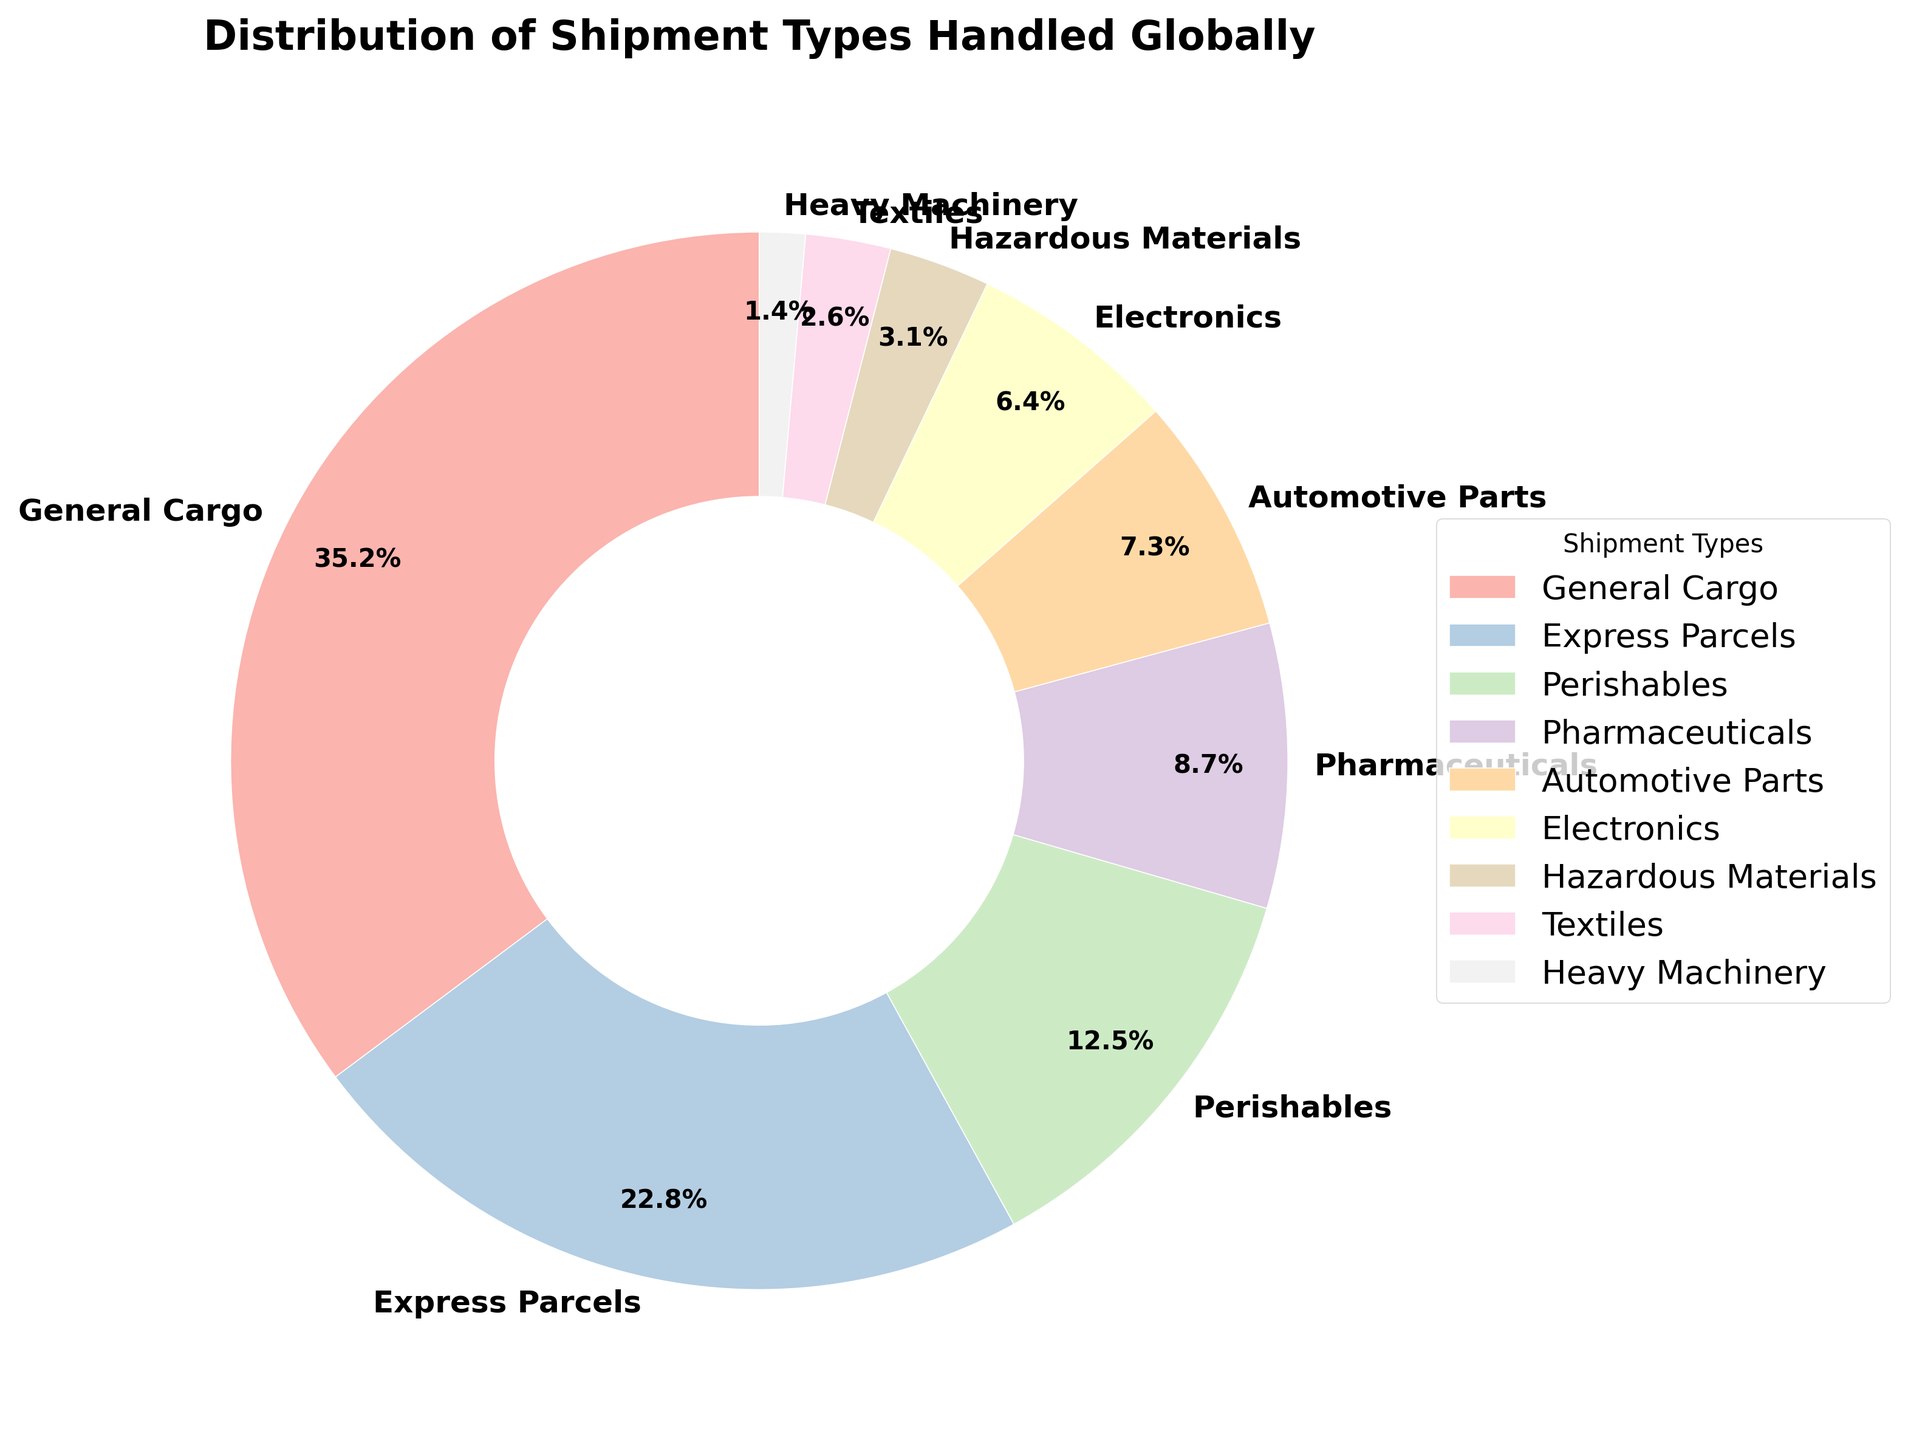Which shipment type has the highest percentage? By observing the largest segment in the pie chart, we identify it as General Cargo. Its percentage is clearly shown as 35.2%.
Answer: General Cargo What is the combined percentage of Express Parcels and Perishables? First, find the percentage of Express Parcels (22.8%) and Perishables (12.5%). Then sum them up: 22.8% + 12.5% = 35.3%.
Answer: 35.3% Which shipment type has a smaller percentage than Electronics but larger than Textiles? Electronics have a percentage of 6.4% and Textiles have 2.6%. Looking at the pie chart, Automotive Parts have 7.3% and Pharmaceuticals have 8.7%, but only Hazardous Materials at 3.1% fits the criteria.
Answer: Hazardous Materials What is the total percentage of all shipment types handled? Sum all the percentages given: 35.2% + 22.8% + 12.5% + 8.7% + 7.3% + 6.4% + 3.1% + 2.6% + 1.4% = 100%.
Answer: 100% How much larger is the percentage of General Cargo compared to Electronics? Subtract the percentage of Electronics (6.4%) from General Cargo (35.2%): 35.2% - 6.4% = 28.8%.
Answer: 28.8% Is the percentage of Pharmaceuticals higher or lower than Automotive Parts? Comparing the values, Pharmaceuticals have 8.7% and Automotive Parts have 7.3%. Pharmaceuticals is higher.
Answer: Higher Which two shipment types combined make up less than 10% of the total shipments? By examining segments, Textiles at 2.6% and Heavy Machinery at 1.4% sum to 4%, which is less than 10%.
Answer: Textiles and Heavy Machinery What is the average percentage of Perishables, Pharmaceuticals, and Electronics? Find the percentages: Perishables (12.5%), Pharmaceuticals (8.7%), and Electronics (6.4%). Sum these values: 12.5% + 8.7% + 6.4% = 27.6%. The average is 27.6% / 3 = 9.2%.
Answer: 9.2% What is the percentage difference between Express Parcels and Hazardous Materials? Subtract the percentage of Hazardous Materials (3.1%) from Express Parcels (22.8%): 22.8% - 3.1% = 19.7%.
Answer: 19.7% Which shipment type has the smallest percentage, and what is it? By looking at the smallest segment, Heavy Machinery is the smallest with 1.4%.
Answer: Heavy Machinery 